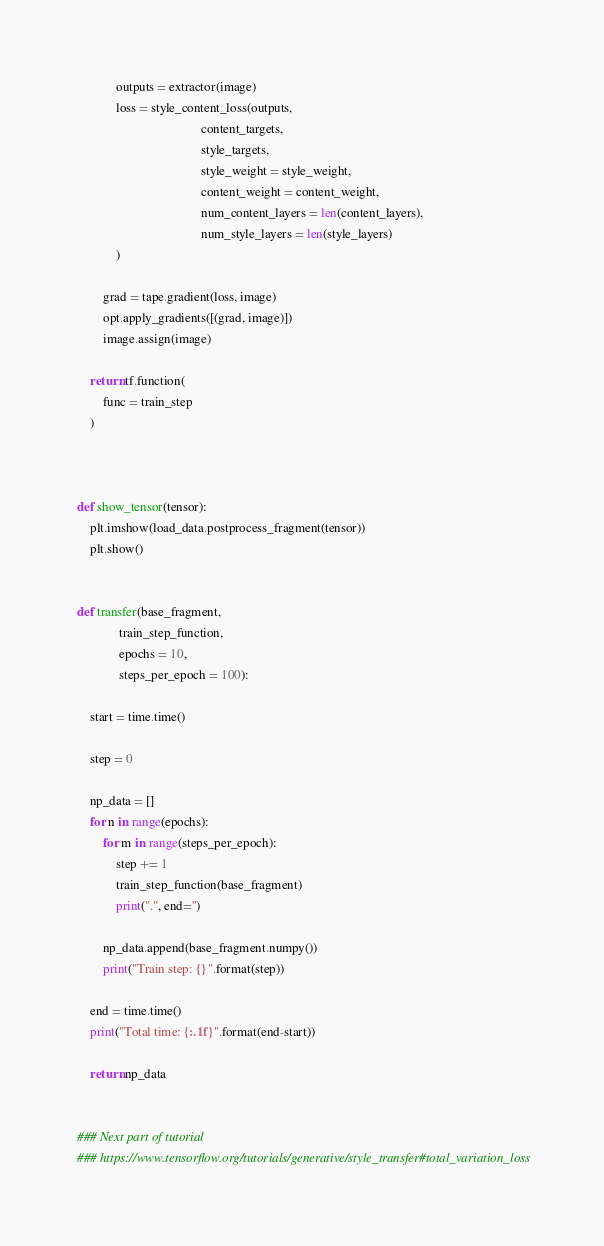Convert code to text. <code><loc_0><loc_0><loc_500><loc_500><_Python_>            outputs = extractor(image)
            loss = style_content_loss(outputs,
                                      content_targets,
                                      style_targets,
                                      style_weight = style_weight,
                                      content_weight = content_weight,
                                      num_content_layers = len(content_layers),
                                      num_style_layers = len(style_layers)
            )

        grad = tape.gradient(loss, image)
        opt.apply_gradients([(grad, image)])
        image.assign(image)

    return tf.function(
        func = train_step
    )



def show_tensor(tensor):
    plt.imshow(load_data.postprocess_fragment(tensor))
    plt.show()


def transfer(base_fragment,
             train_step_function,
             epochs = 10,
             steps_per_epoch = 100):
    
    start = time.time()

    step = 0

    np_data = []
    for n in range(epochs):
        for m in range(steps_per_epoch):
            step += 1
            train_step_function(base_fragment)
            print(".", end='')

        np_data.append(base_fragment.numpy())
        print("Train step: {}".format(step))
  
    end = time.time()
    print("Total time: {:.1f}".format(end-start))

    return np_data


### Next part of tutorial
### https://www.tensorflow.org/tutorials/generative/style_transfer#total_variation_loss
</code> 